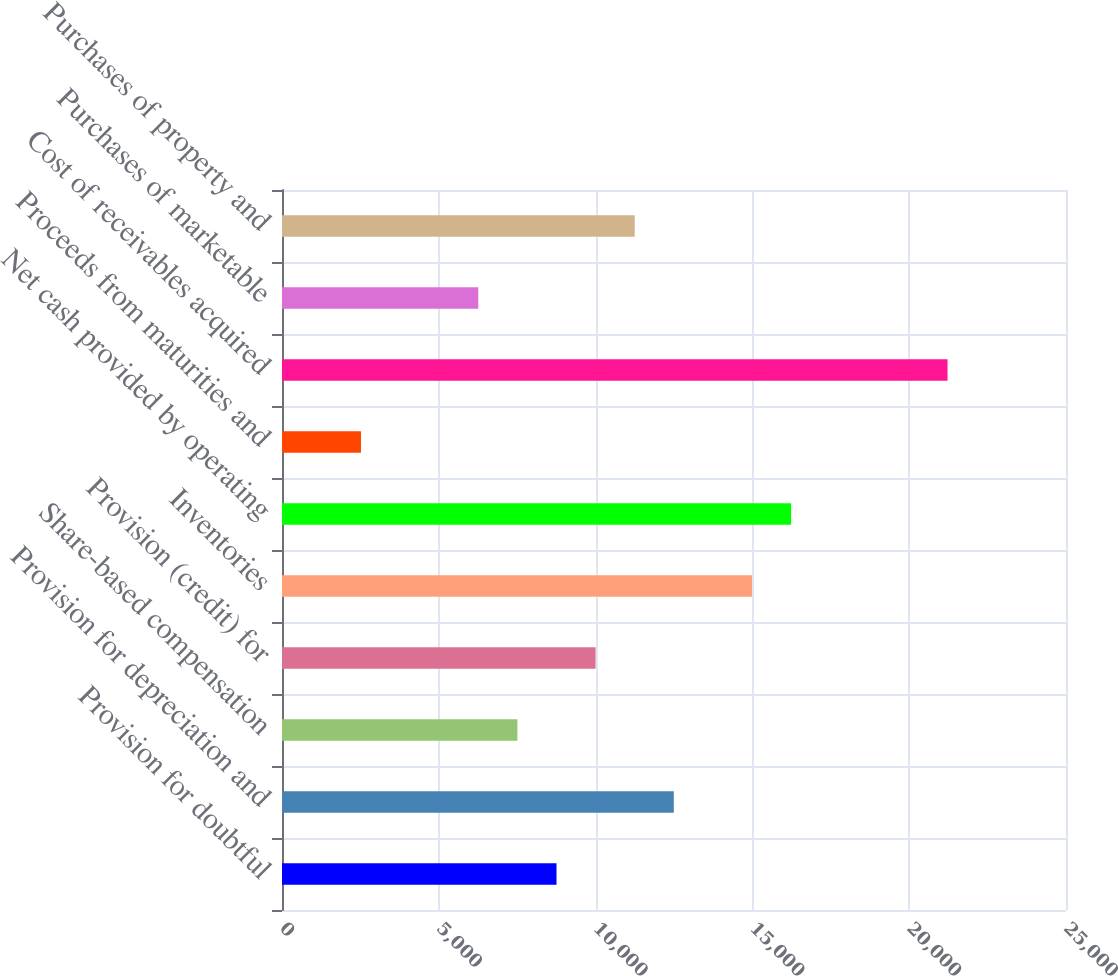Convert chart. <chart><loc_0><loc_0><loc_500><loc_500><bar_chart><fcel>Provision for doubtful<fcel>Provision for depreciation and<fcel>Share-based compensation<fcel>Provision (credit) for<fcel>Inventories<fcel>Net cash provided by operating<fcel>Proceeds from maturities and<fcel>Cost of receivables acquired<fcel>Purchases of marketable<fcel>Purchases of property and<nl><fcel>8753.08<fcel>12493.9<fcel>7506.14<fcel>10000<fcel>14987.8<fcel>16234.7<fcel>2518.38<fcel>21222.5<fcel>6259.2<fcel>11247<nl></chart> 